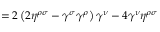Convert formula to latex. <formula><loc_0><loc_0><loc_500><loc_500>= 2 \left ( 2 \eta ^ { \rho \sigma } - \gamma ^ { \sigma } \gamma ^ { \rho } \right ) \gamma ^ { \nu } - 4 \gamma ^ { \nu } \eta ^ { \rho \sigma }</formula> 